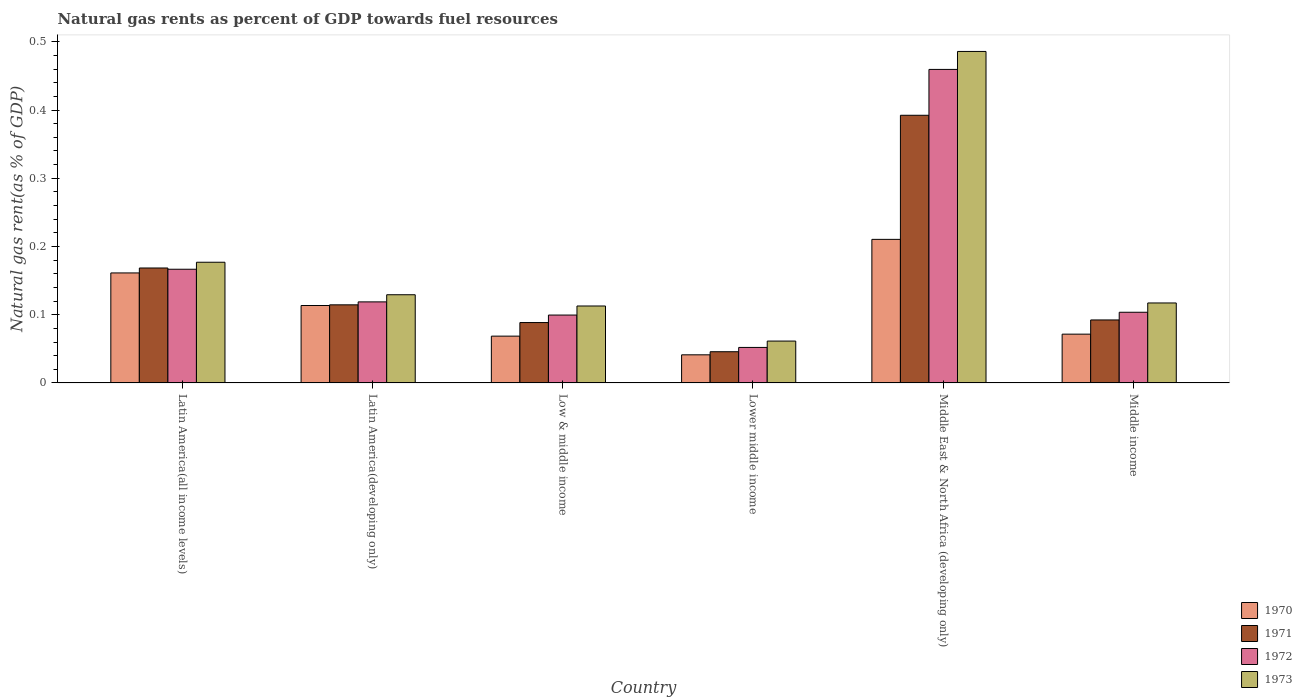Are the number of bars per tick equal to the number of legend labels?
Ensure brevity in your answer.  Yes. How many bars are there on the 4th tick from the left?
Ensure brevity in your answer.  4. What is the label of the 4th group of bars from the left?
Ensure brevity in your answer.  Lower middle income. What is the natural gas rent in 1973 in Latin America(developing only)?
Offer a terse response. 0.13. Across all countries, what is the maximum natural gas rent in 1972?
Make the answer very short. 0.46. Across all countries, what is the minimum natural gas rent in 1973?
Your response must be concise. 0.06. In which country was the natural gas rent in 1971 maximum?
Make the answer very short. Middle East & North Africa (developing only). In which country was the natural gas rent in 1973 minimum?
Make the answer very short. Lower middle income. What is the total natural gas rent in 1971 in the graph?
Keep it short and to the point. 0.9. What is the difference between the natural gas rent in 1970 in Latin America(all income levels) and that in Middle income?
Provide a succinct answer. 0.09. What is the difference between the natural gas rent in 1972 in Low & middle income and the natural gas rent in 1970 in Middle East & North Africa (developing only)?
Give a very brief answer. -0.11. What is the average natural gas rent in 1972 per country?
Keep it short and to the point. 0.17. What is the difference between the natural gas rent of/in 1972 and natural gas rent of/in 1973 in Lower middle income?
Your answer should be very brief. -0.01. What is the ratio of the natural gas rent in 1972 in Latin America(developing only) to that in Low & middle income?
Provide a succinct answer. 1.19. Is the difference between the natural gas rent in 1972 in Latin America(all income levels) and Lower middle income greater than the difference between the natural gas rent in 1973 in Latin America(all income levels) and Lower middle income?
Make the answer very short. No. What is the difference between the highest and the second highest natural gas rent in 1971?
Provide a short and direct response. 0.22. What is the difference between the highest and the lowest natural gas rent in 1972?
Give a very brief answer. 0.41. Is it the case that in every country, the sum of the natural gas rent in 1972 and natural gas rent in 1970 is greater than the sum of natural gas rent in 1971 and natural gas rent in 1973?
Your response must be concise. No. What does the 4th bar from the left in Latin America(developing only) represents?
Keep it short and to the point. 1973. Is it the case that in every country, the sum of the natural gas rent in 1972 and natural gas rent in 1971 is greater than the natural gas rent in 1973?
Keep it short and to the point. Yes. Are all the bars in the graph horizontal?
Your answer should be very brief. No. How many countries are there in the graph?
Give a very brief answer. 6. Are the values on the major ticks of Y-axis written in scientific E-notation?
Make the answer very short. No. Does the graph contain any zero values?
Make the answer very short. No. What is the title of the graph?
Keep it short and to the point. Natural gas rents as percent of GDP towards fuel resources. Does "2013" appear as one of the legend labels in the graph?
Ensure brevity in your answer.  No. What is the label or title of the X-axis?
Offer a very short reply. Country. What is the label or title of the Y-axis?
Offer a very short reply. Natural gas rent(as % of GDP). What is the Natural gas rent(as % of GDP) of 1970 in Latin America(all income levels)?
Your answer should be compact. 0.16. What is the Natural gas rent(as % of GDP) of 1971 in Latin America(all income levels)?
Your answer should be very brief. 0.17. What is the Natural gas rent(as % of GDP) in 1972 in Latin America(all income levels)?
Offer a terse response. 0.17. What is the Natural gas rent(as % of GDP) in 1973 in Latin America(all income levels)?
Make the answer very short. 0.18. What is the Natural gas rent(as % of GDP) in 1970 in Latin America(developing only)?
Your answer should be compact. 0.11. What is the Natural gas rent(as % of GDP) in 1971 in Latin America(developing only)?
Your answer should be very brief. 0.11. What is the Natural gas rent(as % of GDP) in 1972 in Latin America(developing only)?
Your answer should be compact. 0.12. What is the Natural gas rent(as % of GDP) in 1973 in Latin America(developing only)?
Keep it short and to the point. 0.13. What is the Natural gas rent(as % of GDP) in 1970 in Low & middle income?
Provide a short and direct response. 0.07. What is the Natural gas rent(as % of GDP) of 1971 in Low & middle income?
Your answer should be compact. 0.09. What is the Natural gas rent(as % of GDP) of 1972 in Low & middle income?
Offer a very short reply. 0.1. What is the Natural gas rent(as % of GDP) in 1973 in Low & middle income?
Offer a very short reply. 0.11. What is the Natural gas rent(as % of GDP) of 1970 in Lower middle income?
Provide a short and direct response. 0.04. What is the Natural gas rent(as % of GDP) in 1971 in Lower middle income?
Provide a short and direct response. 0.05. What is the Natural gas rent(as % of GDP) in 1972 in Lower middle income?
Give a very brief answer. 0.05. What is the Natural gas rent(as % of GDP) in 1973 in Lower middle income?
Offer a very short reply. 0.06. What is the Natural gas rent(as % of GDP) of 1970 in Middle East & North Africa (developing only)?
Your answer should be very brief. 0.21. What is the Natural gas rent(as % of GDP) of 1971 in Middle East & North Africa (developing only)?
Offer a very short reply. 0.39. What is the Natural gas rent(as % of GDP) in 1972 in Middle East & North Africa (developing only)?
Make the answer very short. 0.46. What is the Natural gas rent(as % of GDP) in 1973 in Middle East & North Africa (developing only)?
Your answer should be compact. 0.49. What is the Natural gas rent(as % of GDP) in 1970 in Middle income?
Offer a very short reply. 0.07. What is the Natural gas rent(as % of GDP) of 1971 in Middle income?
Your answer should be compact. 0.09. What is the Natural gas rent(as % of GDP) of 1972 in Middle income?
Give a very brief answer. 0.1. What is the Natural gas rent(as % of GDP) in 1973 in Middle income?
Offer a terse response. 0.12. Across all countries, what is the maximum Natural gas rent(as % of GDP) of 1970?
Your response must be concise. 0.21. Across all countries, what is the maximum Natural gas rent(as % of GDP) in 1971?
Provide a short and direct response. 0.39. Across all countries, what is the maximum Natural gas rent(as % of GDP) in 1972?
Your answer should be very brief. 0.46. Across all countries, what is the maximum Natural gas rent(as % of GDP) of 1973?
Give a very brief answer. 0.49. Across all countries, what is the minimum Natural gas rent(as % of GDP) in 1970?
Your answer should be very brief. 0.04. Across all countries, what is the minimum Natural gas rent(as % of GDP) of 1971?
Give a very brief answer. 0.05. Across all countries, what is the minimum Natural gas rent(as % of GDP) in 1972?
Your answer should be very brief. 0.05. Across all countries, what is the minimum Natural gas rent(as % of GDP) of 1973?
Keep it short and to the point. 0.06. What is the total Natural gas rent(as % of GDP) in 1970 in the graph?
Provide a succinct answer. 0.67. What is the total Natural gas rent(as % of GDP) in 1971 in the graph?
Offer a very short reply. 0.9. What is the total Natural gas rent(as % of GDP) in 1973 in the graph?
Offer a terse response. 1.08. What is the difference between the Natural gas rent(as % of GDP) in 1970 in Latin America(all income levels) and that in Latin America(developing only)?
Your answer should be very brief. 0.05. What is the difference between the Natural gas rent(as % of GDP) in 1971 in Latin America(all income levels) and that in Latin America(developing only)?
Your response must be concise. 0.05. What is the difference between the Natural gas rent(as % of GDP) in 1972 in Latin America(all income levels) and that in Latin America(developing only)?
Provide a succinct answer. 0.05. What is the difference between the Natural gas rent(as % of GDP) of 1973 in Latin America(all income levels) and that in Latin America(developing only)?
Keep it short and to the point. 0.05. What is the difference between the Natural gas rent(as % of GDP) in 1970 in Latin America(all income levels) and that in Low & middle income?
Provide a short and direct response. 0.09. What is the difference between the Natural gas rent(as % of GDP) of 1972 in Latin America(all income levels) and that in Low & middle income?
Your response must be concise. 0.07. What is the difference between the Natural gas rent(as % of GDP) of 1973 in Latin America(all income levels) and that in Low & middle income?
Your answer should be compact. 0.06. What is the difference between the Natural gas rent(as % of GDP) of 1970 in Latin America(all income levels) and that in Lower middle income?
Keep it short and to the point. 0.12. What is the difference between the Natural gas rent(as % of GDP) in 1971 in Latin America(all income levels) and that in Lower middle income?
Give a very brief answer. 0.12. What is the difference between the Natural gas rent(as % of GDP) of 1972 in Latin America(all income levels) and that in Lower middle income?
Offer a terse response. 0.11. What is the difference between the Natural gas rent(as % of GDP) in 1973 in Latin America(all income levels) and that in Lower middle income?
Provide a short and direct response. 0.12. What is the difference between the Natural gas rent(as % of GDP) in 1970 in Latin America(all income levels) and that in Middle East & North Africa (developing only)?
Keep it short and to the point. -0.05. What is the difference between the Natural gas rent(as % of GDP) of 1971 in Latin America(all income levels) and that in Middle East & North Africa (developing only)?
Provide a short and direct response. -0.22. What is the difference between the Natural gas rent(as % of GDP) of 1972 in Latin America(all income levels) and that in Middle East & North Africa (developing only)?
Ensure brevity in your answer.  -0.29. What is the difference between the Natural gas rent(as % of GDP) of 1973 in Latin America(all income levels) and that in Middle East & North Africa (developing only)?
Your answer should be very brief. -0.31. What is the difference between the Natural gas rent(as % of GDP) of 1970 in Latin America(all income levels) and that in Middle income?
Your answer should be very brief. 0.09. What is the difference between the Natural gas rent(as % of GDP) in 1971 in Latin America(all income levels) and that in Middle income?
Give a very brief answer. 0.08. What is the difference between the Natural gas rent(as % of GDP) in 1972 in Latin America(all income levels) and that in Middle income?
Offer a terse response. 0.06. What is the difference between the Natural gas rent(as % of GDP) of 1973 in Latin America(all income levels) and that in Middle income?
Ensure brevity in your answer.  0.06. What is the difference between the Natural gas rent(as % of GDP) in 1970 in Latin America(developing only) and that in Low & middle income?
Your answer should be compact. 0.04. What is the difference between the Natural gas rent(as % of GDP) in 1971 in Latin America(developing only) and that in Low & middle income?
Give a very brief answer. 0.03. What is the difference between the Natural gas rent(as % of GDP) of 1972 in Latin America(developing only) and that in Low & middle income?
Your answer should be very brief. 0.02. What is the difference between the Natural gas rent(as % of GDP) in 1973 in Latin America(developing only) and that in Low & middle income?
Keep it short and to the point. 0.02. What is the difference between the Natural gas rent(as % of GDP) in 1970 in Latin America(developing only) and that in Lower middle income?
Offer a terse response. 0.07. What is the difference between the Natural gas rent(as % of GDP) in 1971 in Latin America(developing only) and that in Lower middle income?
Your answer should be very brief. 0.07. What is the difference between the Natural gas rent(as % of GDP) in 1972 in Latin America(developing only) and that in Lower middle income?
Make the answer very short. 0.07. What is the difference between the Natural gas rent(as % of GDP) in 1973 in Latin America(developing only) and that in Lower middle income?
Make the answer very short. 0.07. What is the difference between the Natural gas rent(as % of GDP) in 1970 in Latin America(developing only) and that in Middle East & North Africa (developing only)?
Keep it short and to the point. -0.1. What is the difference between the Natural gas rent(as % of GDP) of 1971 in Latin America(developing only) and that in Middle East & North Africa (developing only)?
Offer a very short reply. -0.28. What is the difference between the Natural gas rent(as % of GDP) in 1972 in Latin America(developing only) and that in Middle East & North Africa (developing only)?
Offer a very short reply. -0.34. What is the difference between the Natural gas rent(as % of GDP) of 1973 in Latin America(developing only) and that in Middle East & North Africa (developing only)?
Your response must be concise. -0.36. What is the difference between the Natural gas rent(as % of GDP) of 1970 in Latin America(developing only) and that in Middle income?
Your response must be concise. 0.04. What is the difference between the Natural gas rent(as % of GDP) of 1971 in Latin America(developing only) and that in Middle income?
Keep it short and to the point. 0.02. What is the difference between the Natural gas rent(as % of GDP) in 1972 in Latin America(developing only) and that in Middle income?
Offer a very short reply. 0.02. What is the difference between the Natural gas rent(as % of GDP) of 1973 in Latin America(developing only) and that in Middle income?
Give a very brief answer. 0.01. What is the difference between the Natural gas rent(as % of GDP) of 1970 in Low & middle income and that in Lower middle income?
Offer a very short reply. 0.03. What is the difference between the Natural gas rent(as % of GDP) in 1971 in Low & middle income and that in Lower middle income?
Make the answer very short. 0.04. What is the difference between the Natural gas rent(as % of GDP) of 1972 in Low & middle income and that in Lower middle income?
Offer a very short reply. 0.05. What is the difference between the Natural gas rent(as % of GDP) in 1973 in Low & middle income and that in Lower middle income?
Provide a short and direct response. 0.05. What is the difference between the Natural gas rent(as % of GDP) of 1970 in Low & middle income and that in Middle East & North Africa (developing only)?
Provide a short and direct response. -0.14. What is the difference between the Natural gas rent(as % of GDP) in 1971 in Low & middle income and that in Middle East & North Africa (developing only)?
Keep it short and to the point. -0.3. What is the difference between the Natural gas rent(as % of GDP) of 1972 in Low & middle income and that in Middle East & North Africa (developing only)?
Your answer should be compact. -0.36. What is the difference between the Natural gas rent(as % of GDP) in 1973 in Low & middle income and that in Middle East & North Africa (developing only)?
Provide a succinct answer. -0.37. What is the difference between the Natural gas rent(as % of GDP) in 1970 in Low & middle income and that in Middle income?
Your answer should be very brief. -0. What is the difference between the Natural gas rent(as % of GDP) in 1971 in Low & middle income and that in Middle income?
Your answer should be very brief. -0. What is the difference between the Natural gas rent(as % of GDP) in 1972 in Low & middle income and that in Middle income?
Offer a terse response. -0. What is the difference between the Natural gas rent(as % of GDP) in 1973 in Low & middle income and that in Middle income?
Your answer should be compact. -0. What is the difference between the Natural gas rent(as % of GDP) in 1970 in Lower middle income and that in Middle East & North Africa (developing only)?
Your response must be concise. -0.17. What is the difference between the Natural gas rent(as % of GDP) of 1971 in Lower middle income and that in Middle East & North Africa (developing only)?
Your answer should be very brief. -0.35. What is the difference between the Natural gas rent(as % of GDP) of 1972 in Lower middle income and that in Middle East & North Africa (developing only)?
Offer a very short reply. -0.41. What is the difference between the Natural gas rent(as % of GDP) in 1973 in Lower middle income and that in Middle East & North Africa (developing only)?
Your answer should be compact. -0.42. What is the difference between the Natural gas rent(as % of GDP) of 1970 in Lower middle income and that in Middle income?
Give a very brief answer. -0.03. What is the difference between the Natural gas rent(as % of GDP) in 1971 in Lower middle income and that in Middle income?
Your response must be concise. -0.05. What is the difference between the Natural gas rent(as % of GDP) in 1972 in Lower middle income and that in Middle income?
Your answer should be very brief. -0.05. What is the difference between the Natural gas rent(as % of GDP) of 1973 in Lower middle income and that in Middle income?
Provide a short and direct response. -0.06. What is the difference between the Natural gas rent(as % of GDP) in 1970 in Middle East & North Africa (developing only) and that in Middle income?
Offer a very short reply. 0.14. What is the difference between the Natural gas rent(as % of GDP) of 1972 in Middle East & North Africa (developing only) and that in Middle income?
Your answer should be compact. 0.36. What is the difference between the Natural gas rent(as % of GDP) in 1973 in Middle East & North Africa (developing only) and that in Middle income?
Your response must be concise. 0.37. What is the difference between the Natural gas rent(as % of GDP) of 1970 in Latin America(all income levels) and the Natural gas rent(as % of GDP) of 1971 in Latin America(developing only)?
Keep it short and to the point. 0.05. What is the difference between the Natural gas rent(as % of GDP) of 1970 in Latin America(all income levels) and the Natural gas rent(as % of GDP) of 1972 in Latin America(developing only)?
Your answer should be very brief. 0.04. What is the difference between the Natural gas rent(as % of GDP) of 1970 in Latin America(all income levels) and the Natural gas rent(as % of GDP) of 1973 in Latin America(developing only)?
Keep it short and to the point. 0.03. What is the difference between the Natural gas rent(as % of GDP) in 1971 in Latin America(all income levels) and the Natural gas rent(as % of GDP) in 1972 in Latin America(developing only)?
Provide a succinct answer. 0.05. What is the difference between the Natural gas rent(as % of GDP) in 1971 in Latin America(all income levels) and the Natural gas rent(as % of GDP) in 1973 in Latin America(developing only)?
Keep it short and to the point. 0.04. What is the difference between the Natural gas rent(as % of GDP) of 1972 in Latin America(all income levels) and the Natural gas rent(as % of GDP) of 1973 in Latin America(developing only)?
Your answer should be very brief. 0.04. What is the difference between the Natural gas rent(as % of GDP) of 1970 in Latin America(all income levels) and the Natural gas rent(as % of GDP) of 1971 in Low & middle income?
Offer a terse response. 0.07. What is the difference between the Natural gas rent(as % of GDP) of 1970 in Latin America(all income levels) and the Natural gas rent(as % of GDP) of 1972 in Low & middle income?
Offer a very short reply. 0.06. What is the difference between the Natural gas rent(as % of GDP) in 1970 in Latin America(all income levels) and the Natural gas rent(as % of GDP) in 1973 in Low & middle income?
Your answer should be very brief. 0.05. What is the difference between the Natural gas rent(as % of GDP) in 1971 in Latin America(all income levels) and the Natural gas rent(as % of GDP) in 1972 in Low & middle income?
Offer a very short reply. 0.07. What is the difference between the Natural gas rent(as % of GDP) of 1971 in Latin America(all income levels) and the Natural gas rent(as % of GDP) of 1973 in Low & middle income?
Your answer should be compact. 0.06. What is the difference between the Natural gas rent(as % of GDP) of 1972 in Latin America(all income levels) and the Natural gas rent(as % of GDP) of 1973 in Low & middle income?
Keep it short and to the point. 0.05. What is the difference between the Natural gas rent(as % of GDP) in 1970 in Latin America(all income levels) and the Natural gas rent(as % of GDP) in 1971 in Lower middle income?
Provide a succinct answer. 0.12. What is the difference between the Natural gas rent(as % of GDP) in 1970 in Latin America(all income levels) and the Natural gas rent(as % of GDP) in 1972 in Lower middle income?
Provide a succinct answer. 0.11. What is the difference between the Natural gas rent(as % of GDP) of 1970 in Latin America(all income levels) and the Natural gas rent(as % of GDP) of 1973 in Lower middle income?
Your answer should be compact. 0.1. What is the difference between the Natural gas rent(as % of GDP) of 1971 in Latin America(all income levels) and the Natural gas rent(as % of GDP) of 1972 in Lower middle income?
Offer a very short reply. 0.12. What is the difference between the Natural gas rent(as % of GDP) in 1971 in Latin America(all income levels) and the Natural gas rent(as % of GDP) in 1973 in Lower middle income?
Your answer should be compact. 0.11. What is the difference between the Natural gas rent(as % of GDP) in 1972 in Latin America(all income levels) and the Natural gas rent(as % of GDP) in 1973 in Lower middle income?
Your answer should be very brief. 0.11. What is the difference between the Natural gas rent(as % of GDP) in 1970 in Latin America(all income levels) and the Natural gas rent(as % of GDP) in 1971 in Middle East & North Africa (developing only)?
Provide a succinct answer. -0.23. What is the difference between the Natural gas rent(as % of GDP) of 1970 in Latin America(all income levels) and the Natural gas rent(as % of GDP) of 1972 in Middle East & North Africa (developing only)?
Give a very brief answer. -0.3. What is the difference between the Natural gas rent(as % of GDP) in 1970 in Latin America(all income levels) and the Natural gas rent(as % of GDP) in 1973 in Middle East & North Africa (developing only)?
Provide a short and direct response. -0.32. What is the difference between the Natural gas rent(as % of GDP) of 1971 in Latin America(all income levels) and the Natural gas rent(as % of GDP) of 1972 in Middle East & North Africa (developing only)?
Keep it short and to the point. -0.29. What is the difference between the Natural gas rent(as % of GDP) of 1971 in Latin America(all income levels) and the Natural gas rent(as % of GDP) of 1973 in Middle East & North Africa (developing only)?
Your answer should be very brief. -0.32. What is the difference between the Natural gas rent(as % of GDP) of 1972 in Latin America(all income levels) and the Natural gas rent(as % of GDP) of 1973 in Middle East & North Africa (developing only)?
Offer a very short reply. -0.32. What is the difference between the Natural gas rent(as % of GDP) of 1970 in Latin America(all income levels) and the Natural gas rent(as % of GDP) of 1971 in Middle income?
Provide a succinct answer. 0.07. What is the difference between the Natural gas rent(as % of GDP) in 1970 in Latin America(all income levels) and the Natural gas rent(as % of GDP) in 1972 in Middle income?
Keep it short and to the point. 0.06. What is the difference between the Natural gas rent(as % of GDP) of 1970 in Latin America(all income levels) and the Natural gas rent(as % of GDP) of 1973 in Middle income?
Give a very brief answer. 0.04. What is the difference between the Natural gas rent(as % of GDP) of 1971 in Latin America(all income levels) and the Natural gas rent(as % of GDP) of 1972 in Middle income?
Provide a short and direct response. 0.06. What is the difference between the Natural gas rent(as % of GDP) of 1971 in Latin America(all income levels) and the Natural gas rent(as % of GDP) of 1973 in Middle income?
Ensure brevity in your answer.  0.05. What is the difference between the Natural gas rent(as % of GDP) in 1972 in Latin America(all income levels) and the Natural gas rent(as % of GDP) in 1973 in Middle income?
Your answer should be very brief. 0.05. What is the difference between the Natural gas rent(as % of GDP) in 1970 in Latin America(developing only) and the Natural gas rent(as % of GDP) in 1971 in Low & middle income?
Your response must be concise. 0.03. What is the difference between the Natural gas rent(as % of GDP) in 1970 in Latin America(developing only) and the Natural gas rent(as % of GDP) in 1972 in Low & middle income?
Offer a very short reply. 0.01. What is the difference between the Natural gas rent(as % of GDP) in 1970 in Latin America(developing only) and the Natural gas rent(as % of GDP) in 1973 in Low & middle income?
Give a very brief answer. 0. What is the difference between the Natural gas rent(as % of GDP) in 1971 in Latin America(developing only) and the Natural gas rent(as % of GDP) in 1972 in Low & middle income?
Your response must be concise. 0.01. What is the difference between the Natural gas rent(as % of GDP) in 1971 in Latin America(developing only) and the Natural gas rent(as % of GDP) in 1973 in Low & middle income?
Keep it short and to the point. 0. What is the difference between the Natural gas rent(as % of GDP) of 1972 in Latin America(developing only) and the Natural gas rent(as % of GDP) of 1973 in Low & middle income?
Provide a succinct answer. 0.01. What is the difference between the Natural gas rent(as % of GDP) of 1970 in Latin America(developing only) and the Natural gas rent(as % of GDP) of 1971 in Lower middle income?
Make the answer very short. 0.07. What is the difference between the Natural gas rent(as % of GDP) of 1970 in Latin America(developing only) and the Natural gas rent(as % of GDP) of 1972 in Lower middle income?
Offer a very short reply. 0.06. What is the difference between the Natural gas rent(as % of GDP) of 1970 in Latin America(developing only) and the Natural gas rent(as % of GDP) of 1973 in Lower middle income?
Keep it short and to the point. 0.05. What is the difference between the Natural gas rent(as % of GDP) of 1971 in Latin America(developing only) and the Natural gas rent(as % of GDP) of 1972 in Lower middle income?
Your response must be concise. 0.06. What is the difference between the Natural gas rent(as % of GDP) of 1971 in Latin America(developing only) and the Natural gas rent(as % of GDP) of 1973 in Lower middle income?
Offer a terse response. 0.05. What is the difference between the Natural gas rent(as % of GDP) of 1972 in Latin America(developing only) and the Natural gas rent(as % of GDP) of 1973 in Lower middle income?
Offer a terse response. 0.06. What is the difference between the Natural gas rent(as % of GDP) of 1970 in Latin America(developing only) and the Natural gas rent(as % of GDP) of 1971 in Middle East & North Africa (developing only)?
Provide a succinct answer. -0.28. What is the difference between the Natural gas rent(as % of GDP) of 1970 in Latin America(developing only) and the Natural gas rent(as % of GDP) of 1972 in Middle East & North Africa (developing only)?
Provide a short and direct response. -0.35. What is the difference between the Natural gas rent(as % of GDP) in 1970 in Latin America(developing only) and the Natural gas rent(as % of GDP) in 1973 in Middle East & North Africa (developing only)?
Make the answer very short. -0.37. What is the difference between the Natural gas rent(as % of GDP) of 1971 in Latin America(developing only) and the Natural gas rent(as % of GDP) of 1972 in Middle East & North Africa (developing only)?
Your response must be concise. -0.35. What is the difference between the Natural gas rent(as % of GDP) in 1971 in Latin America(developing only) and the Natural gas rent(as % of GDP) in 1973 in Middle East & North Africa (developing only)?
Your answer should be compact. -0.37. What is the difference between the Natural gas rent(as % of GDP) of 1972 in Latin America(developing only) and the Natural gas rent(as % of GDP) of 1973 in Middle East & North Africa (developing only)?
Make the answer very short. -0.37. What is the difference between the Natural gas rent(as % of GDP) of 1970 in Latin America(developing only) and the Natural gas rent(as % of GDP) of 1971 in Middle income?
Provide a succinct answer. 0.02. What is the difference between the Natural gas rent(as % of GDP) of 1970 in Latin America(developing only) and the Natural gas rent(as % of GDP) of 1972 in Middle income?
Offer a terse response. 0.01. What is the difference between the Natural gas rent(as % of GDP) of 1970 in Latin America(developing only) and the Natural gas rent(as % of GDP) of 1973 in Middle income?
Offer a very short reply. -0. What is the difference between the Natural gas rent(as % of GDP) in 1971 in Latin America(developing only) and the Natural gas rent(as % of GDP) in 1972 in Middle income?
Your response must be concise. 0.01. What is the difference between the Natural gas rent(as % of GDP) of 1971 in Latin America(developing only) and the Natural gas rent(as % of GDP) of 1973 in Middle income?
Keep it short and to the point. -0. What is the difference between the Natural gas rent(as % of GDP) in 1972 in Latin America(developing only) and the Natural gas rent(as % of GDP) in 1973 in Middle income?
Your response must be concise. 0. What is the difference between the Natural gas rent(as % of GDP) in 1970 in Low & middle income and the Natural gas rent(as % of GDP) in 1971 in Lower middle income?
Make the answer very short. 0.02. What is the difference between the Natural gas rent(as % of GDP) of 1970 in Low & middle income and the Natural gas rent(as % of GDP) of 1972 in Lower middle income?
Your response must be concise. 0.02. What is the difference between the Natural gas rent(as % of GDP) of 1970 in Low & middle income and the Natural gas rent(as % of GDP) of 1973 in Lower middle income?
Provide a succinct answer. 0.01. What is the difference between the Natural gas rent(as % of GDP) of 1971 in Low & middle income and the Natural gas rent(as % of GDP) of 1972 in Lower middle income?
Your response must be concise. 0.04. What is the difference between the Natural gas rent(as % of GDP) of 1971 in Low & middle income and the Natural gas rent(as % of GDP) of 1973 in Lower middle income?
Your answer should be compact. 0.03. What is the difference between the Natural gas rent(as % of GDP) of 1972 in Low & middle income and the Natural gas rent(as % of GDP) of 1973 in Lower middle income?
Your answer should be very brief. 0.04. What is the difference between the Natural gas rent(as % of GDP) in 1970 in Low & middle income and the Natural gas rent(as % of GDP) in 1971 in Middle East & North Africa (developing only)?
Your response must be concise. -0.32. What is the difference between the Natural gas rent(as % of GDP) in 1970 in Low & middle income and the Natural gas rent(as % of GDP) in 1972 in Middle East & North Africa (developing only)?
Ensure brevity in your answer.  -0.39. What is the difference between the Natural gas rent(as % of GDP) of 1970 in Low & middle income and the Natural gas rent(as % of GDP) of 1973 in Middle East & North Africa (developing only)?
Provide a short and direct response. -0.42. What is the difference between the Natural gas rent(as % of GDP) in 1971 in Low & middle income and the Natural gas rent(as % of GDP) in 1972 in Middle East & North Africa (developing only)?
Your answer should be compact. -0.37. What is the difference between the Natural gas rent(as % of GDP) in 1971 in Low & middle income and the Natural gas rent(as % of GDP) in 1973 in Middle East & North Africa (developing only)?
Your answer should be compact. -0.4. What is the difference between the Natural gas rent(as % of GDP) in 1972 in Low & middle income and the Natural gas rent(as % of GDP) in 1973 in Middle East & North Africa (developing only)?
Give a very brief answer. -0.39. What is the difference between the Natural gas rent(as % of GDP) of 1970 in Low & middle income and the Natural gas rent(as % of GDP) of 1971 in Middle income?
Offer a terse response. -0.02. What is the difference between the Natural gas rent(as % of GDP) in 1970 in Low & middle income and the Natural gas rent(as % of GDP) in 1972 in Middle income?
Offer a terse response. -0.04. What is the difference between the Natural gas rent(as % of GDP) of 1970 in Low & middle income and the Natural gas rent(as % of GDP) of 1973 in Middle income?
Provide a succinct answer. -0.05. What is the difference between the Natural gas rent(as % of GDP) of 1971 in Low & middle income and the Natural gas rent(as % of GDP) of 1972 in Middle income?
Make the answer very short. -0.02. What is the difference between the Natural gas rent(as % of GDP) in 1971 in Low & middle income and the Natural gas rent(as % of GDP) in 1973 in Middle income?
Give a very brief answer. -0.03. What is the difference between the Natural gas rent(as % of GDP) of 1972 in Low & middle income and the Natural gas rent(as % of GDP) of 1973 in Middle income?
Offer a terse response. -0.02. What is the difference between the Natural gas rent(as % of GDP) of 1970 in Lower middle income and the Natural gas rent(as % of GDP) of 1971 in Middle East & North Africa (developing only)?
Provide a succinct answer. -0.35. What is the difference between the Natural gas rent(as % of GDP) of 1970 in Lower middle income and the Natural gas rent(as % of GDP) of 1972 in Middle East & North Africa (developing only)?
Offer a very short reply. -0.42. What is the difference between the Natural gas rent(as % of GDP) in 1970 in Lower middle income and the Natural gas rent(as % of GDP) in 1973 in Middle East & North Africa (developing only)?
Your answer should be very brief. -0.44. What is the difference between the Natural gas rent(as % of GDP) of 1971 in Lower middle income and the Natural gas rent(as % of GDP) of 1972 in Middle East & North Africa (developing only)?
Ensure brevity in your answer.  -0.41. What is the difference between the Natural gas rent(as % of GDP) in 1971 in Lower middle income and the Natural gas rent(as % of GDP) in 1973 in Middle East & North Africa (developing only)?
Your response must be concise. -0.44. What is the difference between the Natural gas rent(as % of GDP) of 1972 in Lower middle income and the Natural gas rent(as % of GDP) of 1973 in Middle East & North Africa (developing only)?
Provide a short and direct response. -0.43. What is the difference between the Natural gas rent(as % of GDP) in 1970 in Lower middle income and the Natural gas rent(as % of GDP) in 1971 in Middle income?
Provide a short and direct response. -0.05. What is the difference between the Natural gas rent(as % of GDP) in 1970 in Lower middle income and the Natural gas rent(as % of GDP) in 1972 in Middle income?
Make the answer very short. -0.06. What is the difference between the Natural gas rent(as % of GDP) of 1970 in Lower middle income and the Natural gas rent(as % of GDP) of 1973 in Middle income?
Keep it short and to the point. -0.08. What is the difference between the Natural gas rent(as % of GDP) of 1971 in Lower middle income and the Natural gas rent(as % of GDP) of 1972 in Middle income?
Offer a very short reply. -0.06. What is the difference between the Natural gas rent(as % of GDP) in 1971 in Lower middle income and the Natural gas rent(as % of GDP) in 1973 in Middle income?
Offer a terse response. -0.07. What is the difference between the Natural gas rent(as % of GDP) in 1972 in Lower middle income and the Natural gas rent(as % of GDP) in 1973 in Middle income?
Your answer should be very brief. -0.07. What is the difference between the Natural gas rent(as % of GDP) in 1970 in Middle East & North Africa (developing only) and the Natural gas rent(as % of GDP) in 1971 in Middle income?
Ensure brevity in your answer.  0.12. What is the difference between the Natural gas rent(as % of GDP) in 1970 in Middle East & North Africa (developing only) and the Natural gas rent(as % of GDP) in 1972 in Middle income?
Your answer should be compact. 0.11. What is the difference between the Natural gas rent(as % of GDP) in 1970 in Middle East & North Africa (developing only) and the Natural gas rent(as % of GDP) in 1973 in Middle income?
Ensure brevity in your answer.  0.09. What is the difference between the Natural gas rent(as % of GDP) of 1971 in Middle East & North Africa (developing only) and the Natural gas rent(as % of GDP) of 1972 in Middle income?
Ensure brevity in your answer.  0.29. What is the difference between the Natural gas rent(as % of GDP) of 1971 in Middle East & North Africa (developing only) and the Natural gas rent(as % of GDP) of 1973 in Middle income?
Ensure brevity in your answer.  0.28. What is the difference between the Natural gas rent(as % of GDP) in 1972 in Middle East & North Africa (developing only) and the Natural gas rent(as % of GDP) in 1973 in Middle income?
Your answer should be very brief. 0.34. What is the average Natural gas rent(as % of GDP) in 1971 per country?
Keep it short and to the point. 0.15. What is the average Natural gas rent(as % of GDP) in 1973 per country?
Ensure brevity in your answer.  0.18. What is the difference between the Natural gas rent(as % of GDP) of 1970 and Natural gas rent(as % of GDP) of 1971 in Latin America(all income levels)?
Give a very brief answer. -0.01. What is the difference between the Natural gas rent(as % of GDP) of 1970 and Natural gas rent(as % of GDP) of 1972 in Latin America(all income levels)?
Keep it short and to the point. -0.01. What is the difference between the Natural gas rent(as % of GDP) in 1970 and Natural gas rent(as % of GDP) in 1973 in Latin America(all income levels)?
Offer a terse response. -0.02. What is the difference between the Natural gas rent(as % of GDP) of 1971 and Natural gas rent(as % of GDP) of 1972 in Latin America(all income levels)?
Ensure brevity in your answer.  0. What is the difference between the Natural gas rent(as % of GDP) in 1971 and Natural gas rent(as % of GDP) in 1973 in Latin America(all income levels)?
Your response must be concise. -0.01. What is the difference between the Natural gas rent(as % of GDP) in 1972 and Natural gas rent(as % of GDP) in 1973 in Latin America(all income levels)?
Provide a succinct answer. -0.01. What is the difference between the Natural gas rent(as % of GDP) in 1970 and Natural gas rent(as % of GDP) in 1971 in Latin America(developing only)?
Your response must be concise. -0. What is the difference between the Natural gas rent(as % of GDP) in 1970 and Natural gas rent(as % of GDP) in 1972 in Latin America(developing only)?
Provide a succinct answer. -0.01. What is the difference between the Natural gas rent(as % of GDP) in 1970 and Natural gas rent(as % of GDP) in 1973 in Latin America(developing only)?
Your response must be concise. -0.02. What is the difference between the Natural gas rent(as % of GDP) in 1971 and Natural gas rent(as % of GDP) in 1972 in Latin America(developing only)?
Ensure brevity in your answer.  -0. What is the difference between the Natural gas rent(as % of GDP) of 1971 and Natural gas rent(as % of GDP) of 1973 in Latin America(developing only)?
Keep it short and to the point. -0.01. What is the difference between the Natural gas rent(as % of GDP) in 1972 and Natural gas rent(as % of GDP) in 1973 in Latin America(developing only)?
Your answer should be compact. -0.01. What is the difference between the Natural gas rent(as % of GDP) in 1970 and Natural gas rent(as % of GDP) in 1971 in Low & middle income?
Keep it short and to the point. -0.02. What is the difference between the Natural gas rent(as % of GDP) of 1970 and Natural gas rent(as % of GDP) of 1972 in Low & middle income?
Offer a terse response. -0.03. What is the difference between the Natural gas rent(as % of GDP) in 1970 and Natural gas rent(as % of GDP) in 1973 in Low & middle income?
Give a very brief answer. -0.04. What is the difference between the Natural gas rent(as % of GDP) of 1971 and Natural gas rent(as % of GDP) of 1972 in Low & middle income?
Give a very brief answer. -0.01. What is the difference between the Natural gas rent(as % of GDP) in 1971 and Natural gas rent(as % of GDP) in 1973 in Low & middle income?
Keep it short and to the point. -0.02. What is the difference between the Natural gas rent(as % of GDP) of 1972 and Natural gas rent(as % of GDP) of 1973 in Low & middle income?
Keep it short and to the point. -0.01. What is the difference between the Natural gas rent(as % of GDP) in 1970 and Natural gas rent(as % of GDP) in 1971 in Lower middle income?
Give a very brief answer. -0. What is the difference between the Natural gas rent(as % of GDP) of 1970 and Natural gas rent(as % of GDP) of 1972 in Lower middle income?
Make the answer very short. -0.01. What is the difference between the Natural gas rent(as % of GDP) of 1970 and Natural gas rent(as % of GDP) of 1973 in Lower middle income?
Provide a short and direct response. -0.02. What is the difference between the Natural gas rent(as % of GDP) of 1971 and Natural gas rent(as % of GDP) of 1972 in Lower middle income?
Make the answer very short. -0.01. What is the difference between the Natural gas rent(as % of GDP) of 1971 and Natural gas rent(as % of GDP) of 1973 in Lower middle income?
Your response must be concise. -0.02. What is the difference between the Natural gas rent(as % of GDP) in 1972 and Natural gas rent(as % of GDP) in 1973 in Lower middle income?
Give a very brief answer. -0.01. What is the difference between the Natural gas rent(as % of GDP) of 1970 and Natural gas rent(as % of GDP) of 1971 in Middle East & North Africa (developing only)?
Your answer should be compact. -0.18. What is the difference between the Natural gas rent(as % of GDP) in 1970 and Natural gas rent(as % of GDP) in 1972 in Middle East & North Africa (developing only)?
Provide a short and direct response. -0.25. What is the difference between the Natural gas rent(as % of GDP) in 1970 and Natural gas rent(as % of GDP) in 1973 in Middle East & North Africa (developing only)?
Your answer should be very brief. -0.28. What is the difference between the Natural gas rent(as % of GDP) in 1971 and Natural gas rent(as % of GDP) in 1972 in Middle East & North Africa (developing only)?
Offer a very short reply. -0.07. What is the difference between the Natural gas rent(as % of GDP) in 1971 and Natural gas rent(as % of GDP) in 1973 in Middle East & North Africa (developing only)?
Offer a very short reply. -0.09. What is the difference between the Natural gas rent(as % of GDP) of 1972 and Natural gas rent(as % of GDP) of 1973 in Middle East & North Africa (developing only)?
Offer a very short reply. -0.03. What is the difference between the Natural gas rent(as % of GDP) in 1970 and Natural gas rent(as % of GDP) in 1971 in Middle income?
Provide a succinct answer. -0.02. What is the difference between the Natural gas rent(as % of GDP) in 1970 and Natural gas rent(as % of GDP) in 1972 in Middle income?
Give a very brief answer. -0.03. What is the difference between the Natural gas rent(as % of GDP) in 1970 and Natural gas rent(as % of GDP) in 1973 in Middle income?
Ensure brevity in your answer.  -0.05. What is the difference between the Natural gas rent(as % of GDP) in 1971 and Natural gas rent(as % of GDP) in 1972 in Middle income?
Offer a terse response. -0.01. What is the difference between the Natural gas rent(as % of GDP) of 1971 and Natural gas rent(as % of GDP) of 1973 in Middle income?
Ensure brevity in your answer.  -0.02. What is the difference between the Natural gas rent(as % of GDP) of 1972 and Natural gas rent(as % of GDP) of 1973 in Middle income?
Offer a terse response. -0.01. What is the ratio of the Natural gas rent(as % of GDP) in 1970 in Latin America(all income levels) to that in Latin America(developing only)?
Provide a succinct answer. 1.42. What is the ratio of the Natural gas rent(as % of GDP) in 1971 in Latin America(all income levels) to that in Latin America(developing only)?
Your answer should be compact. 1.47. What is the ratio of the Natural gas rent(as % of GDP) in 1972 in Latin America(all income levels) to that in Latin America(developing only)?
Keep it short and to the point. 1.4. What is the ratio of the Natural gas rent(as % of GDP) in 1973 in Latin America(all income levels) to that in Latin America(developing only)?
Make the answer very short. 1.37. What is the ratio of the Natural gas rent(as % of GDP) in 1970 in Latin America(all income levels) to that in Low & middle income?
Make the answer very short. 2.35. What is the ratio of the Natural gas rent(as % of GDP) in 1971 in Latin America(all income levels) to that in Low & middle income?
Your response must be concise. 1.9. What is the ratio of the Natural gas rent(as % of GDP) of 1972 in Latin America(all income levels) to that in Low & middle income?
Provide a short and direct response. 1.67. What is the ratio of the Natural gas rent(as % of GDP) of 1973 in Latin America(all income levels) to that in Low & middle income?
Give a very brief answer. 1.57. What is the ratio of the Natural gas rent(as % of GDP) in 1970 in Latin America(all income levels) to that in Lower middle income?
Offer a terse response. 3.91. What is the ratio of the Natural gas rent(as % of GDP) in 1971 in Latin America(all income levels) to that in Lower middle income?
Keep it short and to the point. 3.68. What is the ratio of the Natural gas rent(as % of GDP) of 1972 in Latin America(all income levels) to that in Lower middle income?
Offer a very short reply. 3.2. What is the ratio of the Natural gas rent(as % of GDP) in 1973 in Latin America(all income levels) to that in Lower middle income?
Provide a short and direct response. 2.88. What is the ratio of the Natural gas rent(as % of GDP) in 1970 in Latin America(all income levels) to that in Middle East & North Africa (developing only)?
Your response must be concise. 0.77. What is the ratio of the Natural gas rent(as % of GDP) in 1971 in Latin America(all income levels) to that in Middle East & North Africa (developing only)?
Your answer should be very brief. 0.43. What is the ratio of the Natural gas rent(as % of GDP) in 1972 in Latin America(all income levels) to that in Middle East & North Africa (developing only)?
Your answer should be compact. 0.36. What is the ratio of the Natural gas rent(as % of GDP) of 1973 in Latin America(all income levels) to that in Middle East & North Africa (developing only)?
Your response must be concise. 0.36. What is the ratio of the Natural gas rent(as % of GDP) in 1970 in Latin America(all income levels) to that in Middle income?
Your answer should be compact. 2.25. What is the ratio of the Natural gas rent(as % of GDP) of 1971 in Latin America(all income levels) to that in Middle income?
Keep it short and to the point. 1.82. What is the ratio of the Natural gas rent(as % of GDP) of 1972 in Latin America(all income levels) to that in Middle income?
Keep it short and to the point. 1.61. What is the ratio of the Natural gas rent(as % of GDP) in 1973 in Latin America(all income levels) to that in Middle income?
Make the answer very short. 1.51. What is the ratio of the Natural gas rent(as % of GDP) in 1970 in Latin America(developing only) to that in Low & middle income?
Ensure brevity in your answer.  1.65. What is the ratio of the Natural gas rent(as % of GDP) of 1971 in Latin America(developing only) to that in Low & middle income?
Offer a very short reply. 1.29. What is the ratio of the Natural gas rent(as % of GDP) in 1972 in Latin America(developing only) to that in Low & middle income?
Offer a terse response. 1.19. What is the ratio of the Natural gas rent(as % of GDP) of 1973 in Latin America(developing only) to that in Low & middle income?
Your answer should be compact. 1.15. What is the ratio of the Natural gas rent(as % of GDP) of 1970 in Latin America(developing only) to that in Lower middle income?
Your answer should be very brief. 2.75. What is the ratio of the Natural gas rent(as % of GDP) in 1971 in Latin America(developing only) to that in Lower middle income?
Offer a terse response. 2.5. What is the ratio of the Natural gas rent(as % of GDP) in 1972 in Latin America(developing only) to that in Lower middle income?
Your answer should be compact. 2.28. What is the ratio of the Natural gas rent(as % of GDP) of 1973 in Latin America(developing only) to that in Lower middle income?
Provide a short and direct response. 2.11. What is the ratio of the Natural gas rent(as % of GDP) of 1970 in Latin America(developing only) to that in Middle East & North Africa (developing only)?
Keep it short and to the point. 0.54. What is the ratio of the Natural gas rent(as % of GDP) in 1971 in Latin America(developing only) to that in Middle East & North Africa (developing only)?
Your answer should be compact. 0.29. What is the ratio of the Natural gas rent(as % of GDP) of 1972 in Latin America(developing only) to that in Middle East & North Africa (developing only)?
Your answer should be compact. 0.26. What is the ratio of the Natural gas rent(as % of GDP) of 1973 in Latin America(developing only) to that in Middle East & North Africa (developing only)?
Keep it short and to the point. 0.27. What is the ratio of the Natural gas rent(as % of GDP) of 1970 in Latin America(developing only) to that in Middle income?
Give a very brief answer. 1.59. What is the ratio of the Natural gas rent(as % of GDP) of 1971 in Latin America(developing only) to that in Middle income?
Your answer should be very brief. 1.24. What is the ratio of the Natural gas rent(as % of GDP) of 1972 in Latin America(developing only) to that in Middle income?
Provide a succinct answer. 1.15. What is the ratio of the Natural gas rent(as % of GDP) in 1973 in Latin America(developing only) to that in Middle income?
Keep it short and to the point. 1.1. What is the ratio of the Natural gas rent(as % of GDP) in 1970 in Low & middle income to that in Lower middle income?
Your answer should be compact. 1.66. What is the ratio of the Natural gas rent(as % of GDP) in 1971 in Low & middle income to that in Lower middle income?
Ensure brevity in your answer.  1.93. What is the ratio of the Natural gas rent(as % of GDP) in 1972 in Low & middle income to that in Lower middle income?
Make the answer very short. 1.91. What is the ratio of the Natural gas rent(as % of GDP) in 1973 in Low & middle income to that in Lower middle income?
Offer a terse response. 1.84. What is the ratio of the Natural gas rent(as % of GDP) of 1970 in Low & middle income to that in Middle East & North Africa (developing only)?
Give a very brief answer. 0.33. What is the ratio of the Natural gas rent(as % of GDP) in 1971 in Low & middle income to that in Middle East & North Africa (developing only)?
Offer a terse response. 0.23. What is the ratio of the Natural gas rent(as % of GDP) in 1972 in Low & middle income to that in Middle East & North Africa (developing only)?
Your answer should be very brief. 0.22. What is the ratio of the Natural gas rent(as % of GDP) of 1973 in Low & middle income to that in Middle East & North Africa (developing only)?
Ensure brevity in your answer.  0.23. What is the ratio of the Natural gas rent(as % of GDP) of 1970 in Low & middle income to that in Middle income?
Your answer should be very brief. 0.96. What is the ratio of the Natural gas rent(as % of GDP) of 1971 in Low & middle income to that in Middle income?
Provide a short and direct response. 0.96. What is the ratio of the Natural gas rent(as % of GDP) in 1972 in Low & middle income to that in Middle income?
Make the answer very short. 0.96. What is the ratio of the Natural gas rent(as % of GDP) of 1973 in Low & middle income to that in Middle income?
Ensure brevity in your answer.  0.96. What is the ratio of the Natural gas rent(as % of GDP) of 1970 in Lower middle income to that in Middle East & North Africa (developing only)?
Your answer should be very brief. 0.2. What is the ratio of the Natural gas rent(as % of GDP) in 1971 in Lower middle income to that in Middle East & North Africa (developing only)?
Your response must be concise. 0.12. What is the ratio of the Natural gas rent(as % of GDP) of 1972 in Lower middle income to that in Middle East & North Africa (developing only)?
Ensure brevity in your answer.  0.11. What is the ratio of the Natural gas rent(as % of GDP) of 1973 in Lower middle income to that in Middle East & North Africa (developing only)?
Ensure brevity in your answer.  0.13. What is the ratio of the Natural gas rent(as % of GDP) in 1970 in Lower middle income to that in Middle income?
Your answer should be compact. 0.58. What is the ratio of the Natural gas rent(as % of GDP) of 1971 in Lower middle income to that in Middle income?
Offer a terse response. 0.5. What is the ratio of the Natural gas rent(as % of GDP) in 1972 in Lower middle income to that in Middle income?
Your answer should be compact. 0.5. What is the ratio of the Natural gas rent(as % of GDP) of 1973 in Lower middle income to that in Middle income?
Offer a terse response. 0.52. What is the ratio of the Natural gas rent(as % of GDP) in 1970 in Middle East & North Africa (developing only) to that in Middle income?
Make the answer very short. 2.94. What is the ratio of the Natural gas rent(as % of GDP) of 1971 in Middle East & North Africa (developing only) to that in Middle income?
Offer a very short reply. 4.25. What is the ratio of the Natural gas rent(as % of GDP) of 1972 in Middle East & North Africa (developing only) to that in Middle income?
Keep it short and to the point. 4.44. What is the ratio of the Natural gas rent(as % of GDP) in 1973 in Middle East & North Africa (developing only) to that in Middle income?
Provide a short and direct response. 4.14. What is the difference between the highest and the second highest Natural gas rent(as % of GDP) of 1970?
Your answer should be very brief. 0.05. What is the difference between the highest and the second highest Natural gas rent(as % of GDP) in 1971?
Ensure brevity in your answer.  0.22. What is the difference between the highest and the second highest Natural gas rent(as % of GDP) in 1972?
Provide a succinct answer. 0.29. What is the difference between the highest and the second highest Natural gas rent(as % of GDP) in 1973?
Provide a succinct answer. 0.31. What is the difference between the highest and the lowest Natural gas rent(as % of GDP) in 1970?
Provide a short and direct response. 0.17. What is the difference between the highest and the lowest Natural gas rent(as % of GDP) of 1971?
Offer a very short reply. 0.35. What is the difference between the highest and the lowest Natural gas rent(as % of GDP) in 1972?
Offer a very short reply. 0.41. What is the difference between the highest and the lowest Natural gas rent(as % of GDP) of 1973?
Your response must be concise. 0.42. 